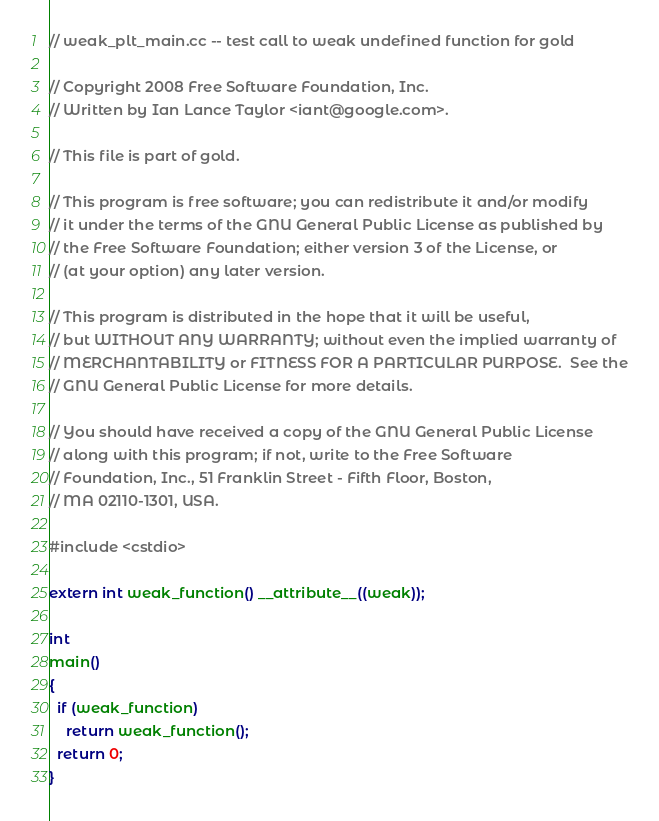Convert code to text. <code><loc_0><loc_0><loc_500><loc_500><_C++_>// weak_plt_main.cc -- test call to weak undefined function for gold

// Copyright 2008 Free Software Foundation, Inc.
// Written by Ian Lance Taylor <iant@google.com>.

// This file is part of gold.

// This program is free software; you can redistribute it and/or modify
// it under the terms of the GNU General Public License as published by
// the Free Software Foundation; either version 3 of the License, or
// (at your option) any later version.

// This program is distributed in the hope that it will be useful,
// but WITHOUT ANY WARRANTY; without even the implied warranty of
// MERCHANTABILITY or FITNESS FOR A PARTICULAR PURPOSE.  See the
// GNU General Public License for more details.

// You should have received a copy of the GNU General Public License
// along with this program; if not, write to the Free Software
// Foundation, Inc., 51 Franklin Street - Fifth Floor, Boston,
// MA 02110-1301, USA.

#include <cstdio>

extern int weak_function() __attribute__((weak));

int
main()
{
  if (weak_function)
    return weak_function();
  return 0;
}
</code> 